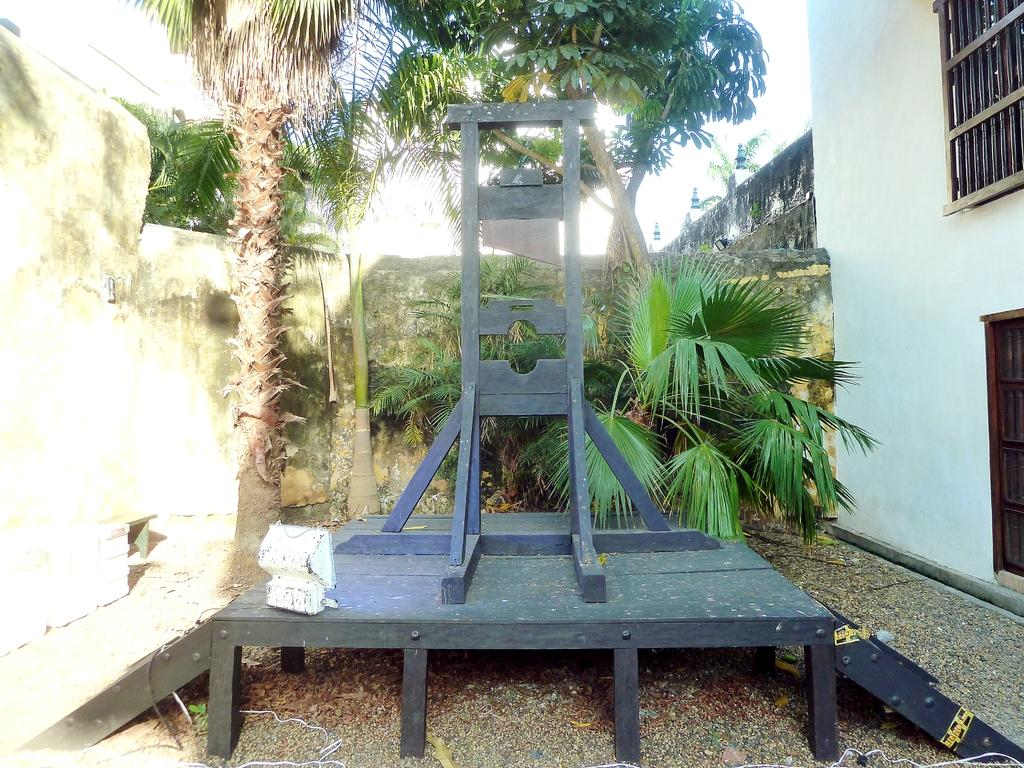What is the main object in the picture? There is a guillotine in the picture. What other elements can be seen in the picture? There are plants, trees, a wall, and a building in the picture. Can you describe the building in the picture? The building has windows on the right side. What is the condition of the sky in the picture? The sky is clear in the picture. How many mice are hiding behind the guillotine in the picture? There are no mice present in the picture; it only features a guillotine, plants, trees, a wall, and a building. What type of sponge is being used to clean the windows on the building? There is no sponge visible in the picture, and the cleaning process of the windows is not depicted. 